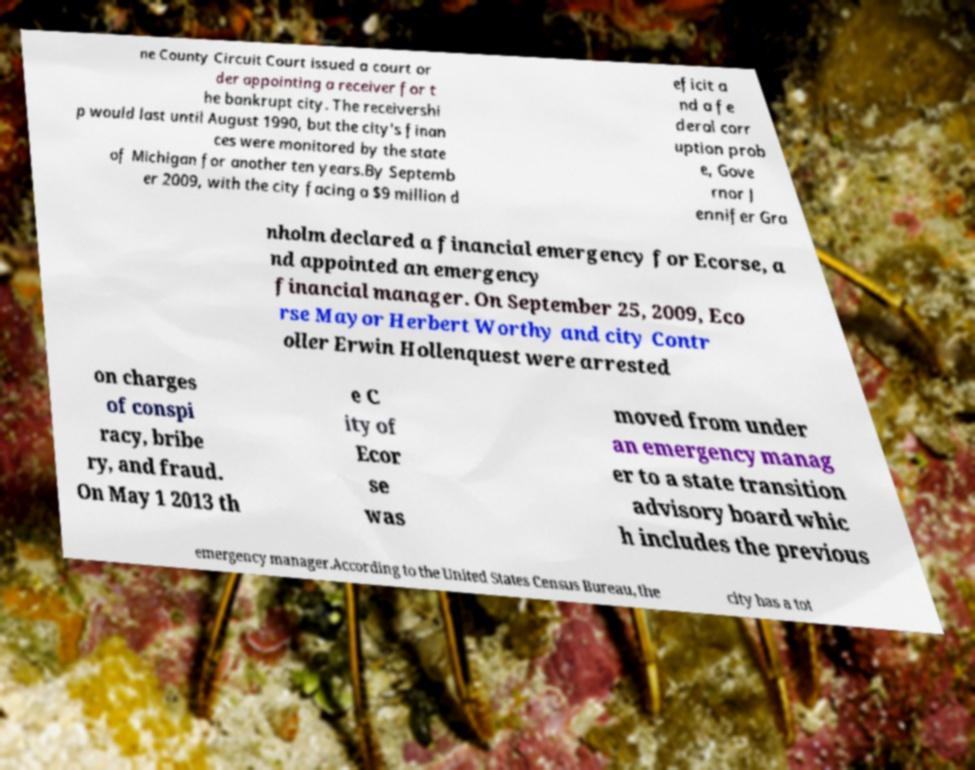Could you extract and type out the text from this image? ne County Circuit Court issued a court or der appointing a receiver for t he bankrupt city. The receivershi p would last until August 1990, but the city's finan ces were monitored by the state of Michigan for another ten years.By Septemb er 2009, with the city facing a $9 million d eficit a nd a fe deral corr uption prob e, Gove rnor J ennifer Gra nholm declared a financial emergency for Ecorse, a nd appointed an emergency financial manager. On September 25, 2009, Eco rse Mayor Herbert Worthy and city Contr oller Erwin Hollenquest were arrested on charges of conspi racy, bribe ry, and fraud. On May 1 2013 th e C ity of Ecor se was moved from under an emergency manag er to a state transition advisory board whic h includes the previous emergency manager.According to the United States Census Bureau, the city has a tot 